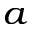<formula> <loc_0><loc_0><loc_500><loc_500>^ { a }</formula> 